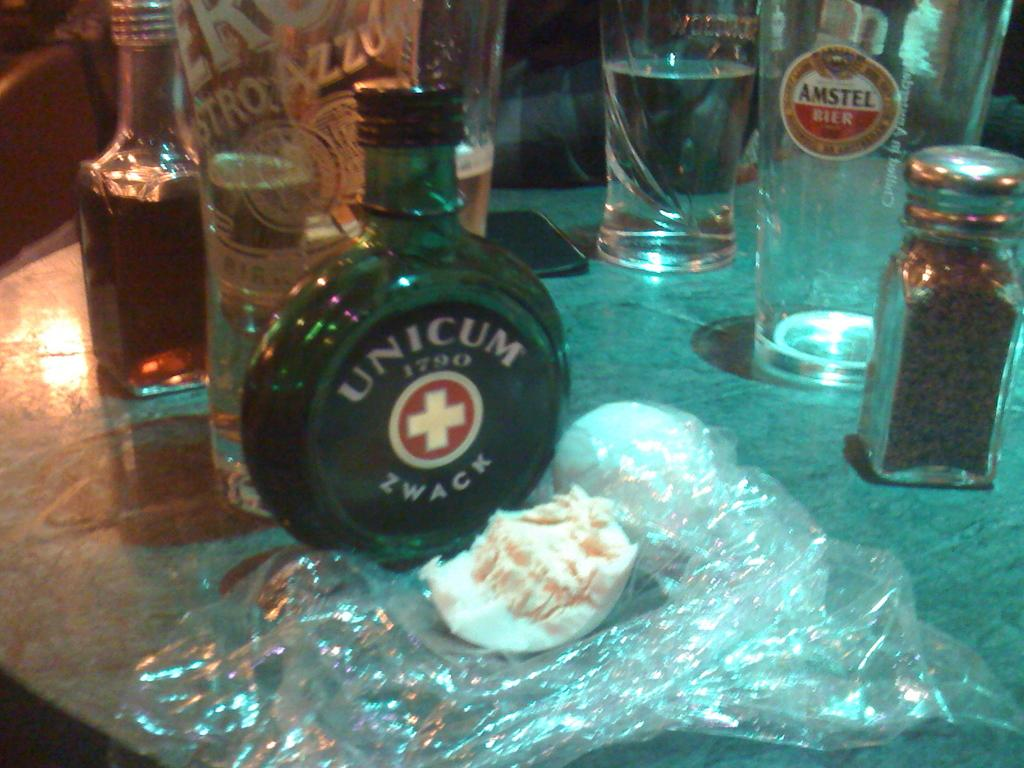<image>
Relay a brief, clear account of the picture shown. The empty pint glas in the background advertised Amstel Beer. 